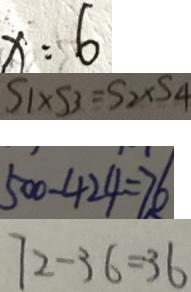Convert formula to latex. <formula><loc_0><loc_0><loc_500><loc_500>x : 6 
 S _ { 1 } \times S _ { 3 } = S _ { 2 } \times S _ { 4 } 
 5 0 0 - 4 2 4 = 7 6 
 7 2 - 3 6 = 3 6</formula> 